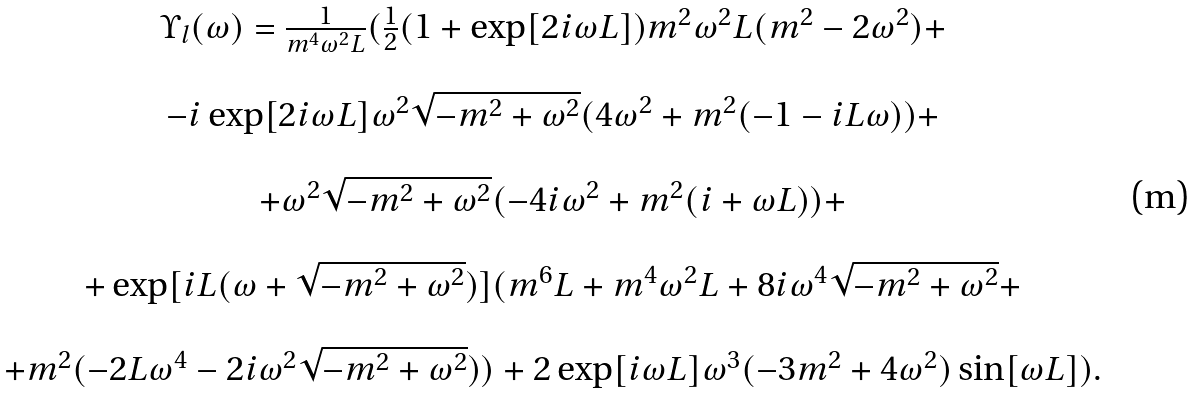<formula> <loc_0><loc_0><loc_500><loc_500>\begin{array} { c } \Upsilon _ { l } ( \omega ) = \frac { 1 } { m ^ { 4 } \omega ^ { 2 } L } ( \frac { 1 } { 2 } ( 1 + \exp [ 2 i \omega L ] ) m ^ { 2 } \omega ^ { 2 } L ( m ^ { 2 } - 2 \omega ^ { 2 } ) + \\ \\ - i \exp [ 2 i \omega L ] \omega ^ { 2 } \sqrt { - m ^ { 2 } + \omega ^ { 2 } } ( 4 \omega ^ { 2 } + m ^ { 2 } ( - 1 - i L \omega ) ) + \\ \\ + \omega ^ { 2 } \sqrt { - m ^ { 2 } + \omega ^ { 2 } } ( - 4 i \omega ^ { 2 } + m ^ { 2 } ( i + \omega L ) ) + \\ \\ + \exp [ i L ( \omega + \sqrt { - m ^ { 2 } + \omega ^ { 2 } } ) ] ( m ^ { 6 } L + m ^ { 4 } \omega ^ { 2 } L + 8 i \omega ^ { 4 } \sqrt { - m ^ { 2 } + \omega ^ { 2 } } + \\ \\ + m ^ { 2 } ( - 2 L \omega ^ { 4 } - 2 i \omega ^ { 2 } \sqrt { - m ^ { 2 } + \omega ^ { 2 } } ) ) + 2 \exp [ i \omega L ] \omega ^ { 3 } ( - 3 m ^ { 2 } + 4 \omega ^ { 2 } ) \sin [ \omega L ] ) . \end{array}</formula> 